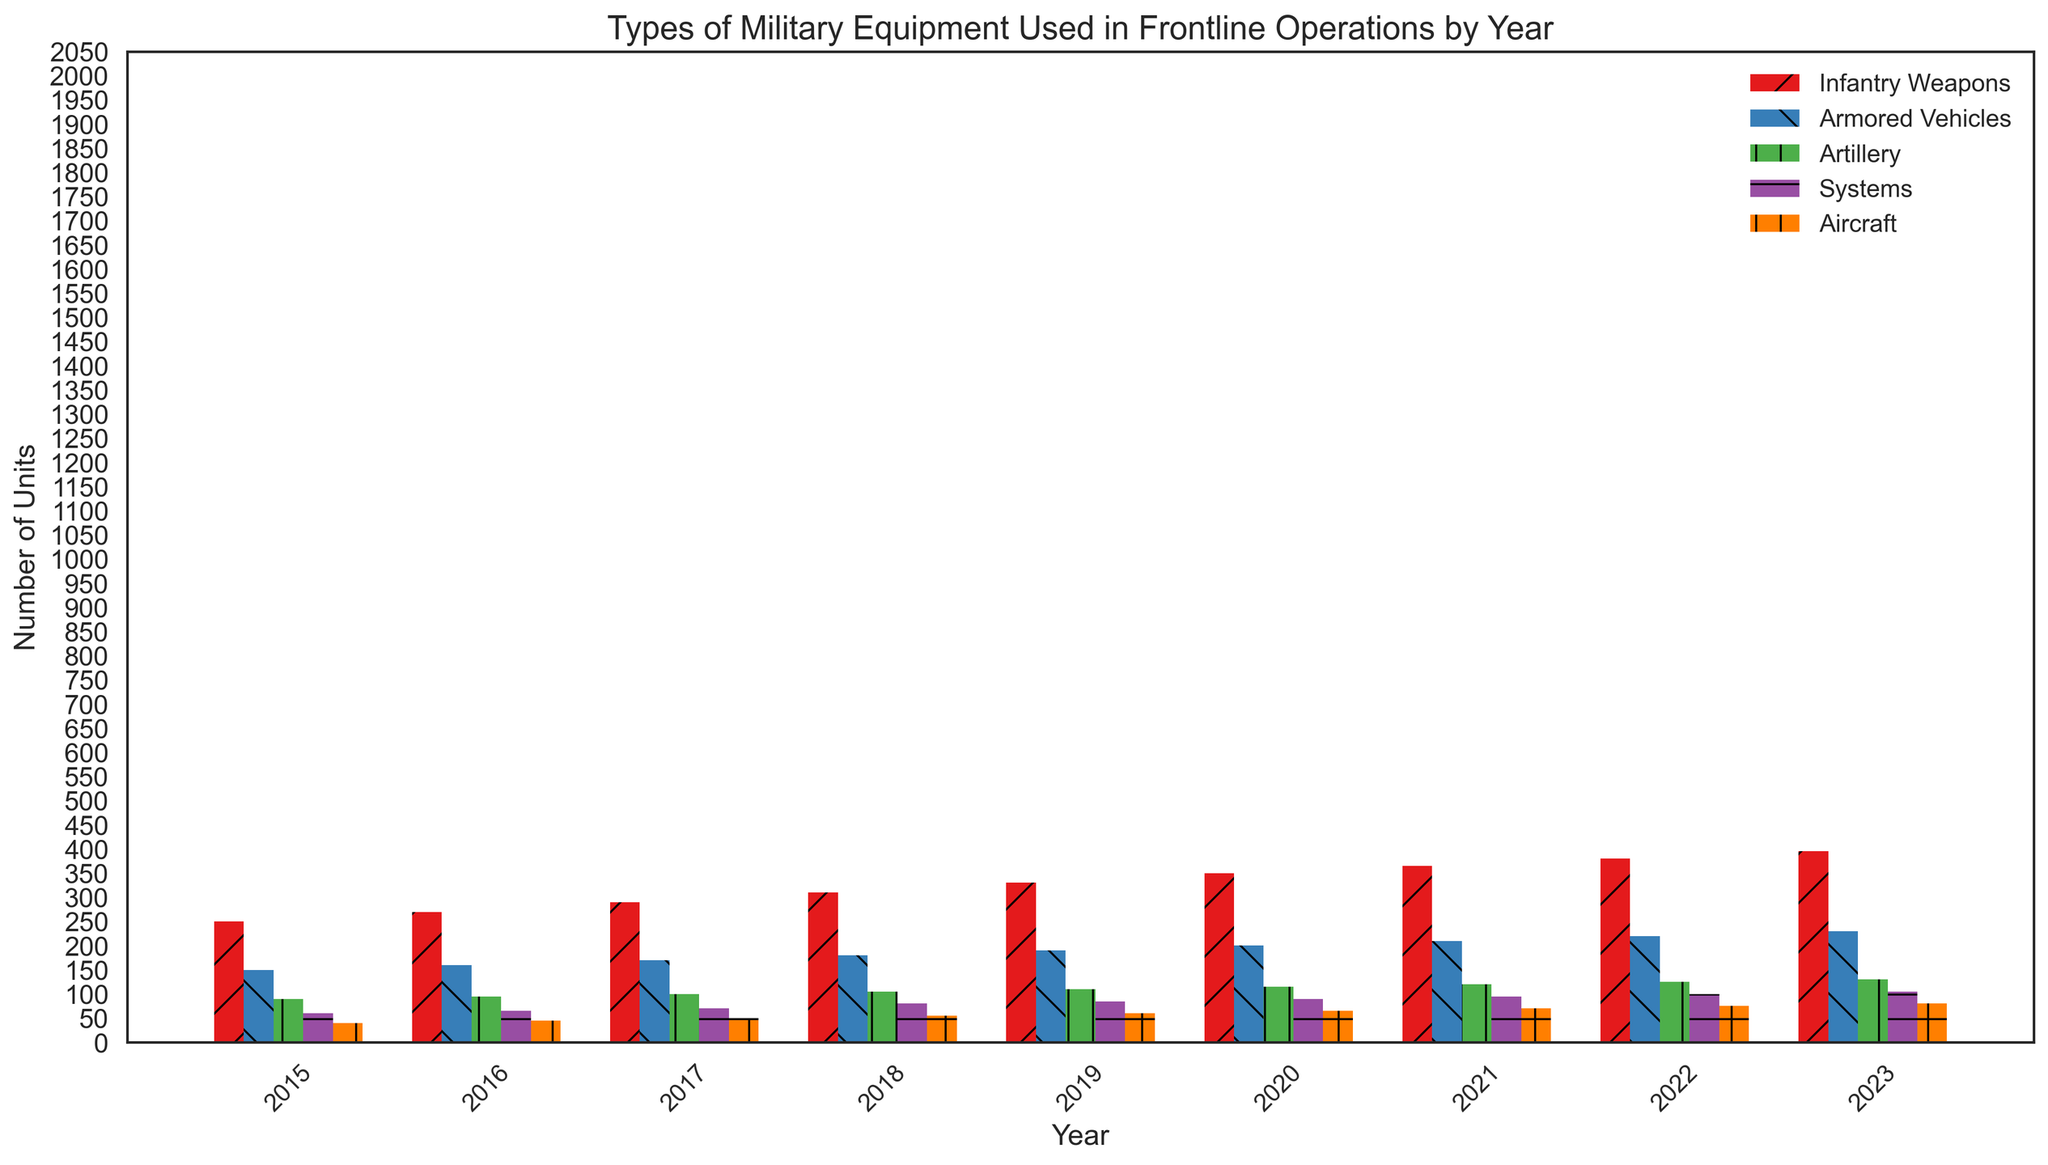Which year had the highest number of Infantry Weapons? By observing the heights of the red bars, we can see that the height increases each year, with 2023 having the tallest bar for Infantry Weapons.
Answer: 2023 How many units of Aircraft were used in 2020? Find the orange bar corresponding to 2020 and observe its height; it is labeled with the value 65.
Answer: 65 Compare the number of Artillery units used in 2017 and 2020. Which year had more units? Locate the green bars for 2017 and 2020. The 2020 bar is taller, indicating more units.
Answer: 2020 What is the difference in the number of Armored Vehicles between 2016 and 2019? Find the heights of the blue bars for 2016 and 2019. The 2016 bar is labeled 160, and the 2019 bar is labeled 190. The difference is 190 - 160 = 30.
Answer: 30 What is the trend of Systems units from 2015 to 2023? Observe the purple bars from 2015 to 2023; the trend shows a gradual increase each year.
Answer: Increased Sum the total number of Artillery units used from 2018 to 2020. Add the green bars' values for 2018 (105), 2019 (110), and 2020 (115). The total is 105 + 110 + 115 = 330.
Answer: 330 How many more Infantry Weapons were used in 2023 compared to 2015? Find the heights of the red bars for 2023 (395) and 2015 (250). The difference is 395 - 250 = 145.
Answer: 145 What is the average number of Aircraft units used from 2015 to 2023? Sum the orange bars' values (40 + 45 + 50 + 55 + 60 + 65 + 70 + 75 + 80) and divide by the number of years (9). The sum is 540, so the average is 540 / 9 = 60.
Answer: 60 Identify the year in which the number of Systems units first exceeded 80. Find the purple bar that first exceeds the height of 80. This occurs in 2018, with a value of 80 itself.
Answer: 2018 